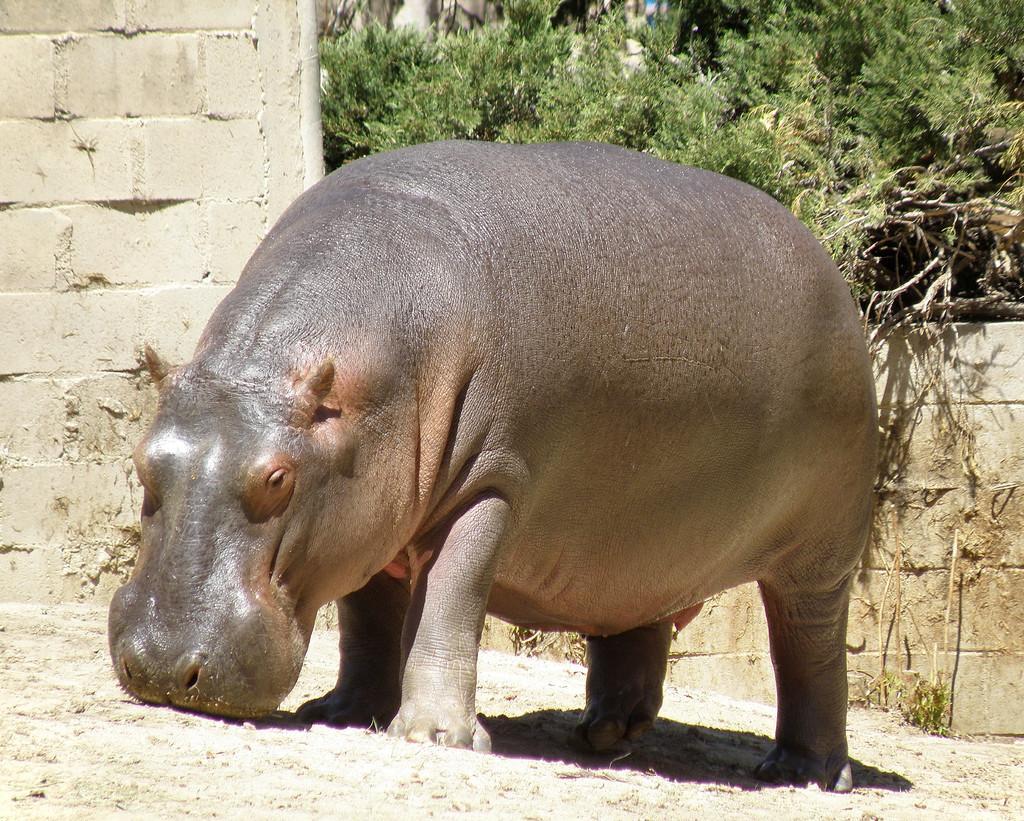Describe this image in one or two sentences. This picture is taken outside of the city and it is sunny. In this image, in the middle, we can see an animal. In the background, we can see a wall, trees. At the bottom, we can see a land with some stones. 